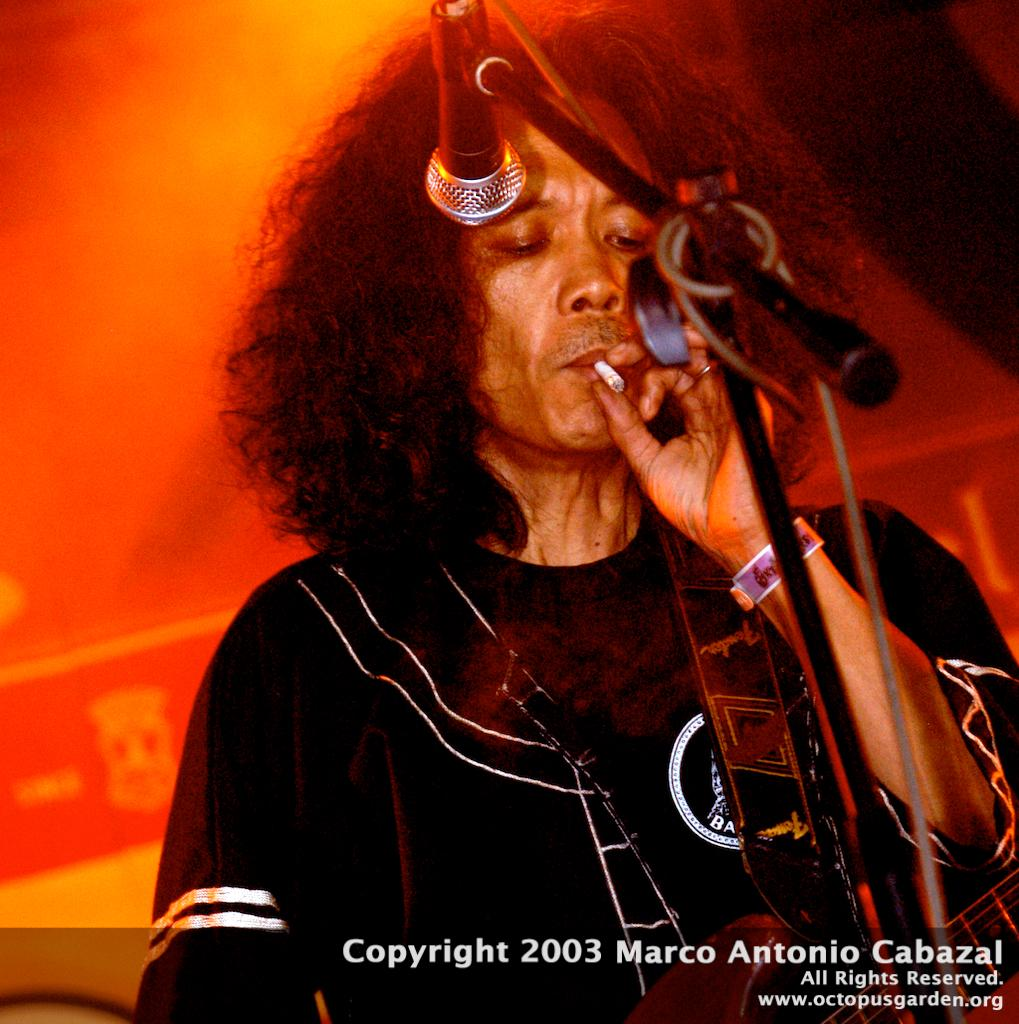What is the main subject of the image? There is a person in the image. What is the person holding in the image? The person is holding a musical instrument and a cigarette. What object is in front of the person? There is a microphone in front of the person. How many toes can be seen on the person's feet in the image? The image does not show the person's feet, so it is impossible to determine the number of toes visible. 